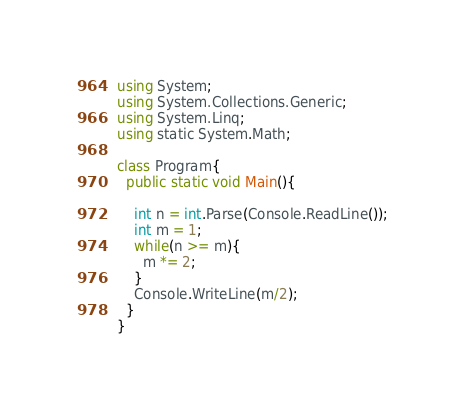Convert code to text. <code><loc_0><loc_0><loc_500><loc_500><_C#_>using System;
using System.Collections.Generic;
using System.Linq;
using static System.Math;

class Program{
  public static void Main(){

    int n = int.Parse(Console.ReadLine());
    int m = 1;
    while(n >= m){
      m *= 2;
    }
    Console.WriteLine(m/2);
  }
}
</code> 